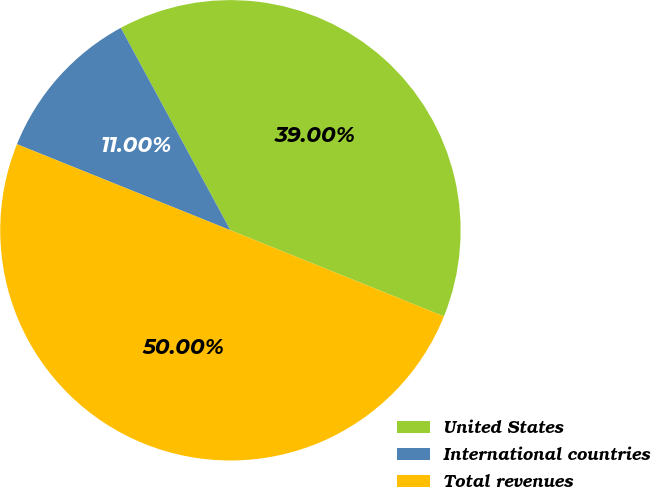Convert chart. <chart><loc_0><loc_0><loc_500><loc_500><pie_chart><fcel>United States<fcel>International countries<fcel>Total revenues<nl><fcel>39.0%<fcel>11.0%<fcel>50.0%<nl></chart> 